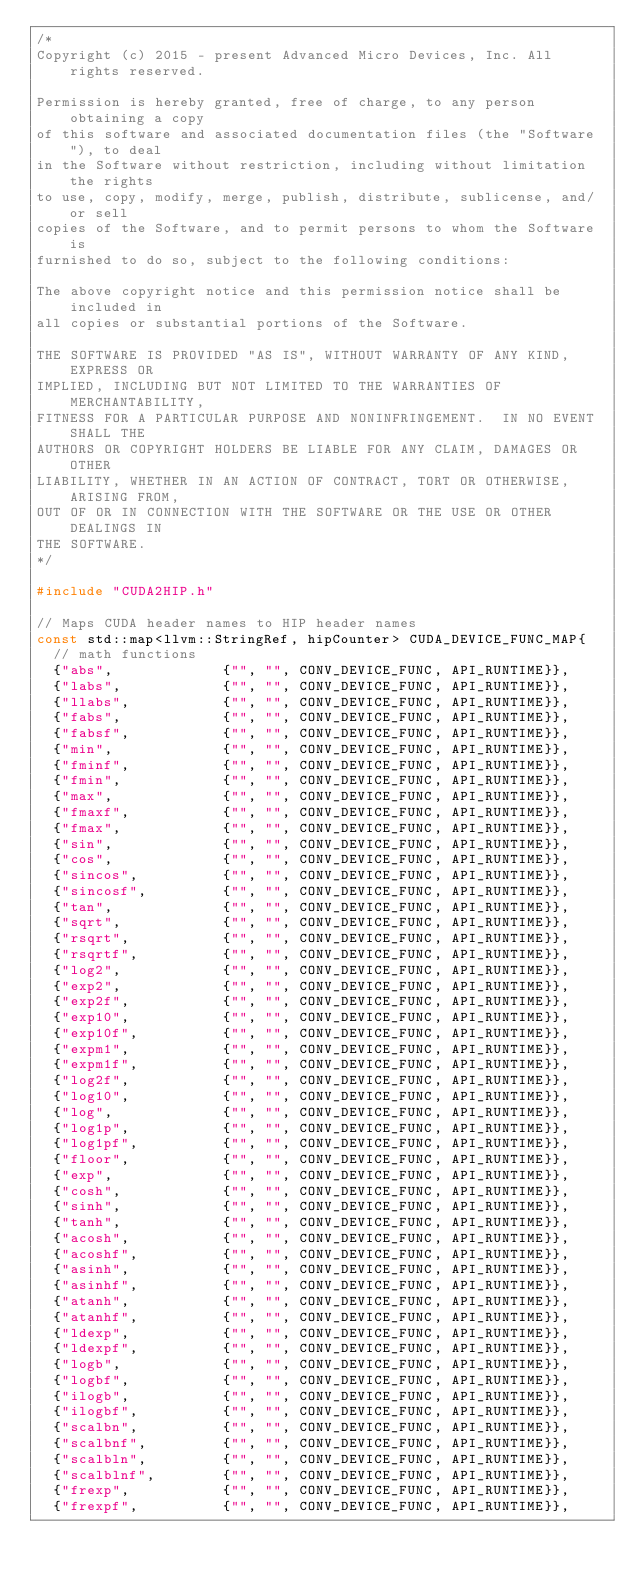<code> <loc_0><loc_0><loc_500><loc_500><_C++_>/*
Copyright (c) 2015 - present Advanced Micro Devices, Inc. All rights reserved.

Permission is hereby granted, free of charge, to any person obtaining a copy
of this software and associated documentation files (the "Software"), to deal
in the Software without restriction, including without limitation the rights
to use, copy, modify, merge, publish, distribute, sublicense, and/or sell
copies of the Software, and to permit persons to whom the Software is
furnished to do so, subject to the following conditions:

The above copyright notice and this permission notice shall be included in
all copies or substantial portions of the Software.

THE SOFTWARE IS PROVIDED "AS IS", WITHOUT WARRANTY OF ANY KIND, EXPRESS OR
IMPLIED, INCLUDING BUT NOT LIMITED TO THE WARRANTIES OF MERCHANTABILITY,
FITNESS FOR A PARTICULAR PURPOSE AND NONINFRINGEMENT.  IN NO EVENT SHALL THE
AUTHORS OR COPYRIGHT HOLDERS BE LIABLE FOR ANY CLAIM, DAMAGES OR OTHER
LIABILITY, WHETHER IN AN ACTION OF CONTRACT, TORT OR OTHERWISE, ARISING FROM,
OUT OF OR IN CONNECTION WITH THE SOFTWARE OR THE USE OR OTHER DEALINGS IN
THE SOFTWARE.
*/

#include "CUDA2HIP.h"

// Maps CUDA header names to HIP header names
const std::map<llvm::StringRef, hipCounter> CUDA_DEVICE_FUNC_MAP{
  // math functions
  {"abs",             {"", "", CONV_DEVICE_FUNC, API_RUNTIME}},
  {"labs",            {"", "", CONV_DEVICE_FUNC, API_RUNTIME}},
  {"llabs",           {"", "", CONV_DEVICE_FUNC, API_RUNTIME}},
  {"fabs",            {"", "", CONV_DEVICE_FUNC, API_RUNTIME}},
  {"fabsf",           {"", "", CONV_DEVICE_FUNC, API_RUNTIME}},
  {"min",             {"", "", CONV_DEVICE_FUNC, API_RUNTIME}},
  {"fminf",           {"", "", CONV_DEVICE_FUNC, API_RUNTIME}},
  {"fmin",            {"", "", CONV_DEVICE_FUNC, API_RUNTIME}},
  {"max",             {"", "", CONV_DEVICE_FUNC, API_RUNTIME}},
  {"fmaxf",           {"", "", CONV_DEVICE_FUNC, API_RUNTIME}},
  {"fmax",            {"", "", CONV_DEVICE_FUNC, API_RUNTIME}},
  {"sin",             {"", "", CONV_DEVICE_FUNC, API_RUNTIME}},
  {"cos",             {"", "", CONV_DEVICE_FUNC, API_RUNTIME}},
  {"sincos",          {"", "", CONV_DEVICE_FUNC, API_RUNTIME}},
  {"sincosf",         {"", "", CONV_DEVICE_FUNC, API_RUNTIME}},
  {"tan",             {"", "", CONV_DEVICE_FUNC, API_RUNTIME}},
  {"sqrt",            {"", "", CONV_DEVICE_FUNC, API_RUNTIME}},
  {"rsqrt",           {"", "", CONV_DEVICE_FUNC, API_RUNTIME}},
  {"rsqrtf",          {"", "", CONV_DEVICE_FUNC, API_RUNTIME}},
  {"log2",            {"", "", CONV_DEVICE_FUNC, API_RUNTIME}},
  {"exp2",            {"", "", CONV_DEVICE_FUNC, API_RUNTIME}},
  {"exp2f",           {"", "", CONV_DEVICE_FUNC, API_RUNTIME}},
  {"exp10",           {"", "", CONV_DEVICE_FUNC, API_RUNTIME}},
  {"exp10f",          {"", "", CONV_DEVICE_FUNC, API_RUNTIME}},
  {"expm1",           {"", "", CONV_DEVICE_FUNC, API_RUNTIME}},
  {"expm1f",          {"", "", CONV_DEVICE_FUNC, API_RUNTIME}},
  {"log2f",           {"", "", CONV_DEVICE_FUNC, API_RUNTIME}},
  {"log10",           {"", "", CONV_DEVICE_FUNC, API_RUNTIME}},
  {"log",             {"", "", CONV_DEVICE_FUNC, API_RUNTIME}},
  {"log1p",           {"", "", CONV_DEVICE_FUNC, API_RUNTIME}},
  {"log1pf",          {"", "", CONV_DEVICE_FUNC, API_RUNTIME}},
  {"floor",           {"", "", CONV_DEVICE_FUNC, API_RUNTIME}},
  {"exp",             {"", "", CONV_DEVICE_FUNC, API_RUNTIME}},
  {"cosh",            {"", "", CONV_DEVICE_FUNC, API_RUNTIME}},
  {"sinh",            {"", "", CONV_DEVICE_FUNC, API_RUNTIME}},
  {"tanh",            {"", "", CONV_DEVICE_FUNC, API_RUNTIME}},
  {"acosh",           {"", "", CONV_DEVICE_FUNC, API_RUNTIME}},
  {"acoshf",          {"", "", CONV_DEVICE_FUNC, API_RUNTIME}},
  {"asinh",           {"", "", CONV_DEVICE_FUNC, API_RUNTIME}},
  {"asinhf",          {"", "", CONV_DEVICE_FUNC, API_RUNTIME}},
  {"atanh",           {"", "", CONV_DEVICE_FUNC, API_RUNTIME}},
  {"atanhf",          {"", "", CONV_DEVICE_FUNC, API_RUNTIME}},
  {"ldexp",           {"", "", CONV_DEVICE_FUNC, API_RUNTIME}},
  {"ldexpf",          {"", "", CONV_DEVICE_FUNC, API_RUNTIME}},
  {"logb",            {"", "", CONV_DEVICE_FUNC, API_RUNTIME}},
  {"logbf",           {"", "", CONV_DEVICE_FUNC, API_RUNTIME}},
  {"ilogb",           {"", "", CONV_DEVICE_FUNC, API_RUNTIME}},
  {"ilogbf",          {"", "", CONV_DEVICE_FUNC, API_RUNTIME}},
  {"scalbn",          {"", "", CONV_DEVICE_FUNC, API_RUNTIME}},
  {"scalbnf",         {"", "", CONV_DEVICE_FUNC, API_RUNTIME}},
  {"scalbln",         {"", "", CONV_DEVICE_FUNC, API_RUNTIME}},
  {"scalblnf",        {"", "", CONV_DEVICE_FUNC, API_RUNTIME}},
  {"frexp",           {"", "", CONV_DEVICE_FUNC, API_RUNTIME}},
  {"frexpf",          {"", "", CONV_DEVICE_FUNC, API_RUNTIME}},</code> 